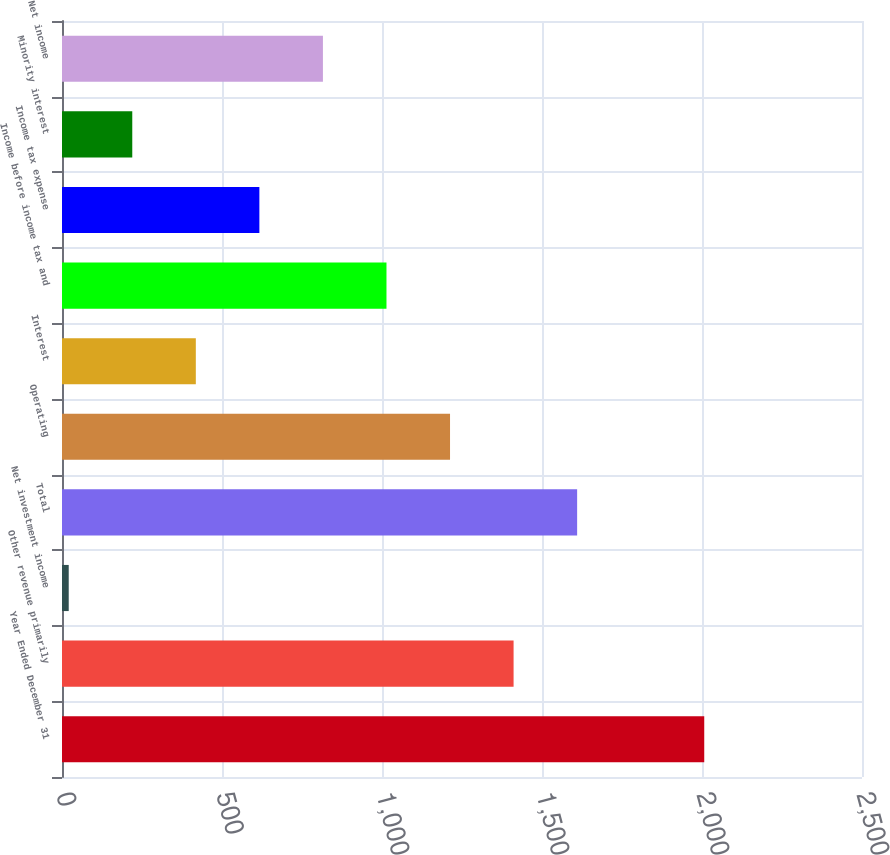Convert chart to OTSL. <chart><loc_0><loc_0><loc_500><loc_500><bar_chart><fcel>Year Ended December 31<fcel>Other revenue primarily<fcel>Net investment income<fcel>Total<fcel>Operating<fcel>Interest<fcel>Income before income tax and<fcel>Income tax expense<fcel>Minority interest<fcel>Net income<nl><fcel>2007<fcel>1411.2<fcel>21<fcel>1609.8<fcel>1212.6<fcel>418.2<fcel>1014<fcel>616.8<fcel>219.6<fcel>815.4<nl></chart> 